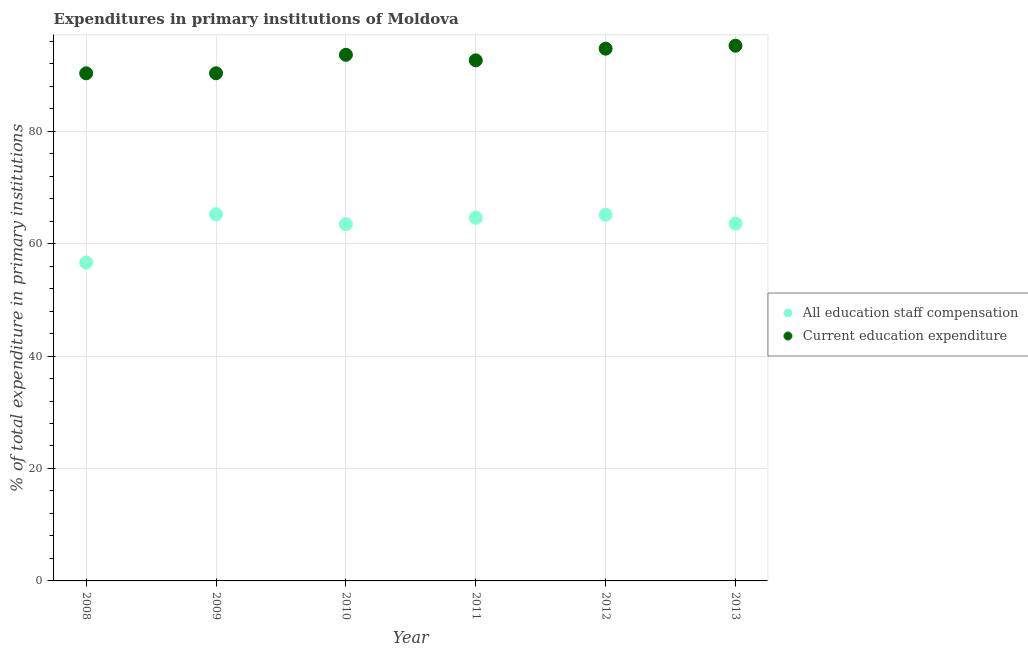What is the expenditure in education in 2008?
Ensure brevity in your answer.  90.28. Across all years, what is the maximum expenditure in education?
Your answer should be compact. 95.19. Across all years, what is the minimum expenditure in education?
Make the answer very short. 90.28. In which year was the expenditure in staff compensation minimum?
Give a very brief answer. 2008. What is the total expenditure in staff compensation in the graph?
Provide a succinct answer. 378.58. What is the difference between the expenditure in staff compensation in 2009 and that in 2011?
Give a very brief answer. 0.63. What is the difference between the expenditure in education in 2012 and the expenditure in staff compensation in 2008?
Your answer should be very brief. 38.04. What is the average expenditure in education per year?
Offer a terse response. 92.77. In the year 2013, what is the difference between the expenditure in staff compensation and expenditure in education?
Your answer should be very brief. -31.63. In how many years, is the expenditure in staff compensation greater than 16 %?
Your answer should be compact. 6. What is the ratio of the expenditure in staff compensation in 2011 to that in 2012?
Keep it short and to the point. 0.99. Is the expenditure in education in 2009 less than that in 2013?
Your answer should be compact. Yes. What is the difference between the highest and the second highest expenditure in staff compensation?
Offer a very short reply. 0.08. What is the difference between the highest and the lowest expenditure in staff compensation?
Your response must be concise. 8.59. Does the expenditure in education monotonically increase over the years?
Give a very brief answer. No. Is the expenditure in staff compensation strictly less than the expenditure in education over the years?
Your response must be concise. Yes. How many dotlines are there?
Provide a short and direct response. 2. What is the difference between two consecutive major ticks on the Y-axis?
Provide a succinct answer. 20. Does the graph contain any zero values?
Keep it short and to the point. No. Does the graph contain grids?
Your answer should be compact. Yes. Where does the legend appear in the graph?
Offer a very short reply. Center right. How many legend labels are there?
Ensure brevity in your answer.  2. What is the title of the graph?
Provide a short and direct response. Expenditures in primary institutions of Moldova. Does "Nitrous oxide" appear as one of the legend labels in the graph?
Give a very brief answer. No. What is the label or title of the X-axis?
Ensure brevity in your answer.  Year. What is the label or title of the Y-axis?
Make the answer very short. % of total expenditure in primary institutions. What is the % of total expenditure in primary institutions in All education staff compensation in 2008?
Provide a short and direct response. 56.62. What is the % of total expenditure in primary institutions in Current education expenditure in 2008?
Keep it short and to the point. 90.28. What is the % of total expenditure in primary institutions in All education staff compensation in 2009?
Provide a succinct answer. 65.22. What is the % of total expenditure in primary institutions in Current education expenditure in 2009?
Your answer should be very brief. 90.29. What is the % of total expenditure in primary institutions of All education staff compensation in 2010?
Ensure brevity in your answer.  63.45. What is the % of total expenditure in primary institutions of Current education expenditure in 2010?
Your answer should be compact. 93.58. What is the % of total expenditure in primary institutions of All education staff compensation in 2011?
Provide a succinct answer. 64.59. What is the % of total expenditure in primary institutions of Current education expenditure in 2011?
Offer a very short reply. 92.59. What is the % of total expenditure in primary institutions in All education staff compensation in 2012?
Offer a terse response. 65.14. What is the % of total expenditure in primary institutions of Current education expenditure in 2012?
Give a very brief answer. 94.67. What is the % of total expenditure in primary institutions of All education staff compensation in 2013?
Provide a succinct answer. 63.56. What is the % of total expenditure in primary institutions of Current education expenditure in 2013?
Offer a terse response. 95.19. Across all years, what is the maximum % of total expenditure in primary institutions in All education staff compensation?
Provide a short and direct response. 65.22. Across all years, what is the maximum % of total expenditure in primary institutions of Current education expenditure?
Give a very brief answer. 95.19. Across all years, what is the minimum % of total expenditure in primary institutions in All education staff compensation?
Offer a very short reply. 56.62. Across all years, what is the minimum % of total expenditure in primary institutions of Current education expenditure?
Keep it short and to the point. 90.28. What is the total % of total expenditure in primary institutions in All education staff compensation in the graph?
Give a very brief answer. 378.58. What is the total % of total expenditure in primary institutions of Current education expenditure in the graph?
Make the answer very short. 556.59. What is the difference between the % of total expenditure in primary institutions in All education staff compensation in 2008 and that in 2009?
Keep it short and to the point. -8.59. What is the difference between the % of total expenditure in primary institutions in Current education expenditure in 2008 and that in 2009?
Give a very brief answer. -0.01. What is the difference between the % of total expenditure in primary institutions in All education staff compensation in 2008 and that in 2010?
Provide a succinct answer. -6.82. What is the difference between the % of total expenditure in primary institutions in Current education expenditure in 2008 and that in 2010?
Your response must be concise. -3.3. What is the difference between the % of total expenditure in primary institutions in All education staff compensation in 2008 and that in 2011?
Offer a terse response. -7.96. What is the difference between the % of total expenditure in primary institutions in Current education expenditure in 2008 and that in 2011?
Make the answer very short. -2.31. What is the difference between the % of total expenditure in primary institutions of All education staff compensation in 2008 and that in 2012?
Offer a terse response. -8.51. What is the difference between the % of total expenditure in primary institutions of Current education expenditure in 2008 and that in 2012?
Offer a very short reply. -4.39. What is the difference between the % of total expenditure in primary institutions of All education staff compensation in 2008 and that in 2013?
Offer a terse response. -6.94. What is the difference between the % of total expenditure in primary institutions in Current education expenditure in 2008 and that in 2013?
Offer a very short reply. -4.91. What is the difference between the % of total expenditure in primary institutions in All education staff compensation in 2009 and that in 2010?
Make the answer very short. 1.77. What is the difference between the % of total expenditure in primary institutions in Current education expenditure in 2009 and that in 2010?
Your response must be concise. -3.29. What is the difference between the % of total expenditure in primary institutions in All education staff compensation in 2009 and that in 2011?
Keep it short and to the point. 0.63. What is the difference between the % of total expenditure in primary institutions in Current education expenditure in 2009 and that in 2011?
Provide a succinct answer. -2.3. What is the difference between the % of total expenditure in primary institutions in All education staff compensation in 2009 and that in 2012?
Make the answer very short. 0.08. What is the difference between the % of total expenditure in primary institutions of Current education expenditure in 2009 and that in 2012?
Your answer should be very brief. -4.38. What is the difference between the % of total expenditure in primary institutions in All education staff compensation in 2009 and that in 2013?
Offer a terse response. 1.65. What is the difference between the % of total expenditure in primary institutions of Current education expenditure in 2009 and that in 2013?
Keep it short and to the point. -4.9. What is the difference between the % of total expenditure in primary institutions of All education staff compensation in 2010 and that in 2011?
Make the answer very short. -1.14. What is the difference between the % of total expenditure in primary institutions of Current education expenditure in 2010 and that in 2011?
Keep it short and to the point. 0.99. What is the difference between the % of total expenditure in primary institutions of All education staff compensation in 2010 and that in 2012?
Make the answer very short. -1.69. What is the difference between the % of total expenditure in primary institutions in Current education expenditure in 2010 and that in 2012?
Offer a very short reply. -1.09. What is the difference between the % of total expenditure in primary institutions in All education staff compensation in 2010 and that in 2013?
Keep it short and to the point. -0.12. What is the difference between the % of total expenditure in primary institutions in Current education expenditure in 2010 and that in 2013?
Your answer should be very brief. -1.61. What is the difference between the % of total expenditure in primary institutions of All education staff compensation in 2011 and that in 2012?
Provide a succinct answer. -0.55. What is the difference between the % of total expenditure in primary institutions of Current education expenditure in 2011 and that in 2012?
Offer a very short reply. -2.08. What is the difference between the % of total expenditure in primary institutions of All education staff compensation in 2011 and that in 2013?
Make the answer very short. 1.02. What is the difference between the % of total expenditure in primary institutions in Current education expenditure in 2011 and that in 2013?
Your response must be concise. -2.6. What is the difference between the % of total expenditure in primary institutions of All education staff compensation in 2012 and that in 2013?
Make the answer very short. 1.57. What is the difference between the % of total expenditure in primary institutions in Current education expenditure in 2012 and that in 2013?
Make the answer very short. -0.52. What is the difference between the % of total expenditure in primary institutions of All education staff compensation in 2008 and the % of total expenditure in primary institutions of Current education expenditure in 2009?
Offer a terse response. -33.66. What is the difference between the % of total expenditure in primary institutions in All education staff compensation in 2008 and the % of total expenditure in primary institutions in Current education expenditure in 2010?
Offer a very short reply. -36.95. What is the difference between the % of total expenditure in primary institutions in All education staff compensation in 2008 and the % of total expenditure in primary institutions in Current education expenditure in 2011?
Offer a very short reply. -35.96. What is the difference between the % of total expenditure in primary institutions in All education staff compensation in 2008 and the % of total expenditure in primary institutions in Current education expenditure in 2012?
Your response must be concise. -38.04. What is the difference between the % of total expenditure in primary institutions in All education staff compensation in 2008 and the % of total expenditure in primary institutions in Current education expenditure in 2013?
Your response must be concise. -38.57. What is the difference between the % of total expenditure in primary institutions of All education staff compensation in 2009 and the % of total expenditure in primary institutions of Current education expenditure in 2010?
Ensure brevity in your answer.  -28.36. What is the difference between the % of total expenditure in primary institutions of All education staff compensation in 2009 and the % of total expenditure in primary institutions of Current education expenditure in 2011?
Your answer should be compact. -27.37. What is the difference between the % of total expenditure in primary institutions of All education staff compensation in 2009 and the % of total expenditure in primary institutions of Current education expenditure in 2012?
Your answer should be very brief. -29.45. What is the difference between the % of total expenditure in primary institutions in All education staff compensation in 2009 and the % of total expenditure in primary institutions in Current education expenditure in 2013?
Your answer should be very brief. -29.97. What is the difference between the % of total expenditure in primary institutions in All education staff compensation in 2010 and the % of total expenditure in primary institutions in Current education expenditure in 2011?
Ensure brevity in your answer.  -29.14. What is the difference between the % of total expenditure in primary institutions in All education staff compensation in 2010 and the % of total expenditure in primary institutions in Current education expenditure in 2012?
Make the answer very short. -31.22. What is the difference between the % of total expenditure in primary institutions of All education staff compensation in 2010 and the % of total expenditure in primary institutions of Current education expenditure in 2013?
Provide a short and direct response. -31.74. What is the difference between the % of total expenditure in primary institutions of All education staff compensation in 2011 and the % of total expenditure in primary institutions of Current education expenditure in 2012?
Your answer should be compact. -30.08. What is the difference between the % of total expenditure in primary institutions of All education staff compensation in 2011 and the % of total expenditure in primary institutions of Current education expenditure in 2013?
Your answer should be very brief. -30.6. What is the difference between the % of total expenditure in primary institutions of All education staff compensation in 2012 and the % of total expenditure in primary institutions of Current education expenditure in 2013?
Offer a terse response. -30.05. What is the average % of total expenditure in primary institutions in All education staff compensation per year?
Ensure brevity in your answer.  63.1. What is the average % of total expenditure in primary institutions in Current education expenditure per year?
Keep it short and to the point. 92.77. In the year 2008, what is the difference between the % of total expenditure in primary institutions in All education staff compensation and % of total expenditure in primary institutions in Current education expenditure?
Your answer should be very brief. -33.66. In the year 2009, what is the difference between the % of total expenditure in primary institutions in All education staff compensation and % of total expenditure in primary institutions in Current education expenditure?
Keep it short and to the point. -25.07. In the year 2010, what is the difference between the % of total expenditure in primary institutions of All education staff compensation and % of total expenditure in primary institutions of Current education expenditure?
Your answer should be very brief. -30.13. In the year 2011, what is the difference between the % of total expenditure in primary institutions of All education staff compensation and % of total expenditure in primary institutions of Current education expenditure?
Make the answer very short. -28. In the year 2012, what is the difference between the % of total expenditure in primary institutions of All education staff compensation and % of total expenditure in primary institutions of Current education expenditure?
Provide a short and direct response. -29.53. In the year 2013, what is the difference between the % of total expenditure in primary institutions of All education staff compensation and % of total expenditure in primary institutions of Current education expenditure?
Offer a very short reply. -31.63. What is the ratio of the % of total expenditure in primary institutions of All education staff compensation in 2008 to that in 2009?
Your answer should be very brief. 0.87. What is the ratio of the % of total expenditure in primary institutions in All education staff compensation in 2008 to that in 2010?
Make the answer very short. 0.89. What is the ratio of the % of total expenditure in primary institutions of Current education expenditure in 2008 to that in 2010?
Offer a very short reply. 0.96. What is the ratio of the % of total expenditure in primary institutions in All education staff compensation in 2008 to that in 2011?
Keep it short and to the point. 0.88. What is the ratio of the % of total expenditure in primary institutions in Current education expenditure in 2008 to that in 2011?
Keep it short and to the point. 0.98. What is the ratio of the % of total expenditure in primary institutions in All education staff compensation in 2008 to that in 2012?
Your answer should be very brief. 0.87. What is the ratio of the % of total expenditure in primary institutions in Current education expenditure in 2008 to that in 2012?
Make the answer very short. 0.95. What is the ratio of the % of total expenditure in primary institutions of All education staff compensation in 2008 to that in 2013?
Offer a very short reply. 0.89. What is the ratio of the % of total expenditure in primary institutions in Current education expenditure in 2008 to that in 2013?
Your answer should be compact. 0.95. What is the ratio of the % of total expenditure in primary institutions in All education staff compensation in 2009 to that in 2010?
Offer a terse response. 1.03. What is the ratio of the % of total expenditure in primary institutions of Current education expenditure in 2009 to that in 2010?
Offer a very short reply. 0.96. What is the ratio of the % of total expenditure in primary institutions in All education staff compensation in 2009 to that in 2011?
Give a very brief answer. 1.01. What is the ratio of the % of total expenditure in primary institutions in Current education expenditure in 2009 to that in 2011?
Your response must be concise. 0.98. What is the ratio of the % of total expenditure in primary institutions in Current education expenditure in 2009 to that in 2012?
Offer a very short reply. 0.95. What is the ratio of the % of total expenditure in primary institutions in Current education expenditure in 2009 to that in 2013?
Your answer should be very brief. 0.95. What is the ratio of the % of total expenditure in primary institutions of All education staff compensation in 2010 to that in 2011?
Give a very brief answer. 0.98. What is the ratio of the % of total expenditure in primary institutions in Current education expenditure in 2010 to that in 2011?
Offer a very short reply. 1.01. What is the ratio of the % of total expenditure in primary institutions of All education staff compensation in 2010 to that in 2012?
Give a very brief answer. 0.97. What is the ratio of the % of total expenditure in primary institutions of Current education expenditure in 2010 to that in 2012?
Provide a succinct answer. 0.99. What is the ratio of the % of total expenditure in primary institutions of All education staff compensation in 2011 to that in 2012?
Give a very brief answer. 0.99. What is the ratio of the % of total expenditure in primary institutions in All education staff compensation in 2011 to that in 2013?
Provide a short and direct response. 1.02. What is the ratio of the % of total expenditure in primary institutions of Current education expenditure in 2011 to that in 2013?
Provide a short and direct response. 0.97. What is the ratio of the % of total expenditure in primary institutions in All education staff compensation in 2012 to that in 2013?
Provide a succinct answer. 1.02. What is the ratio of the % of total expenditure in primary institutions of Current education expenditure in 2012 to that in 2013?
Your answer should be compact. 0.99. What is the difference between the highest and the second highest % of total expenditure in primary institutions in All education staff compensation?
Keep it short and to the point. 0.08. What is the difference between the highest and the second highest % of total expenditure in primary institutions of Current education expenditure?
Give a very brief answer. 0.52. What is the difference between the highest and the lowest % of total expenditure in primary institutions in All education staff compensation?
Provide a short and direct response. 8.59. What is the difference between the highest and the lowest % of total expenditure in primary institutions in Current education expenditure?
Your response must be concise. 4.91. 